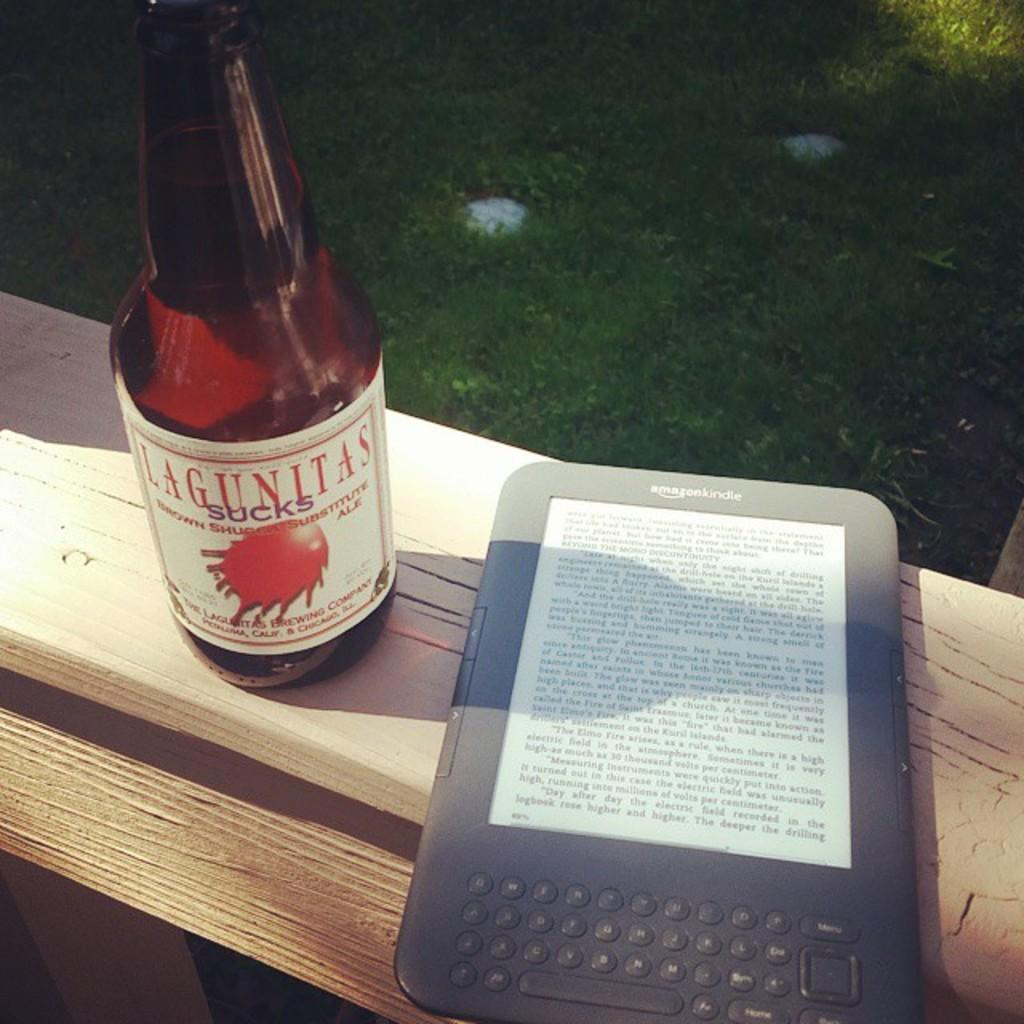Provide a one-sentence caption for the provided image. amazon kindle on board next to bottle of lagunitas sucks. 